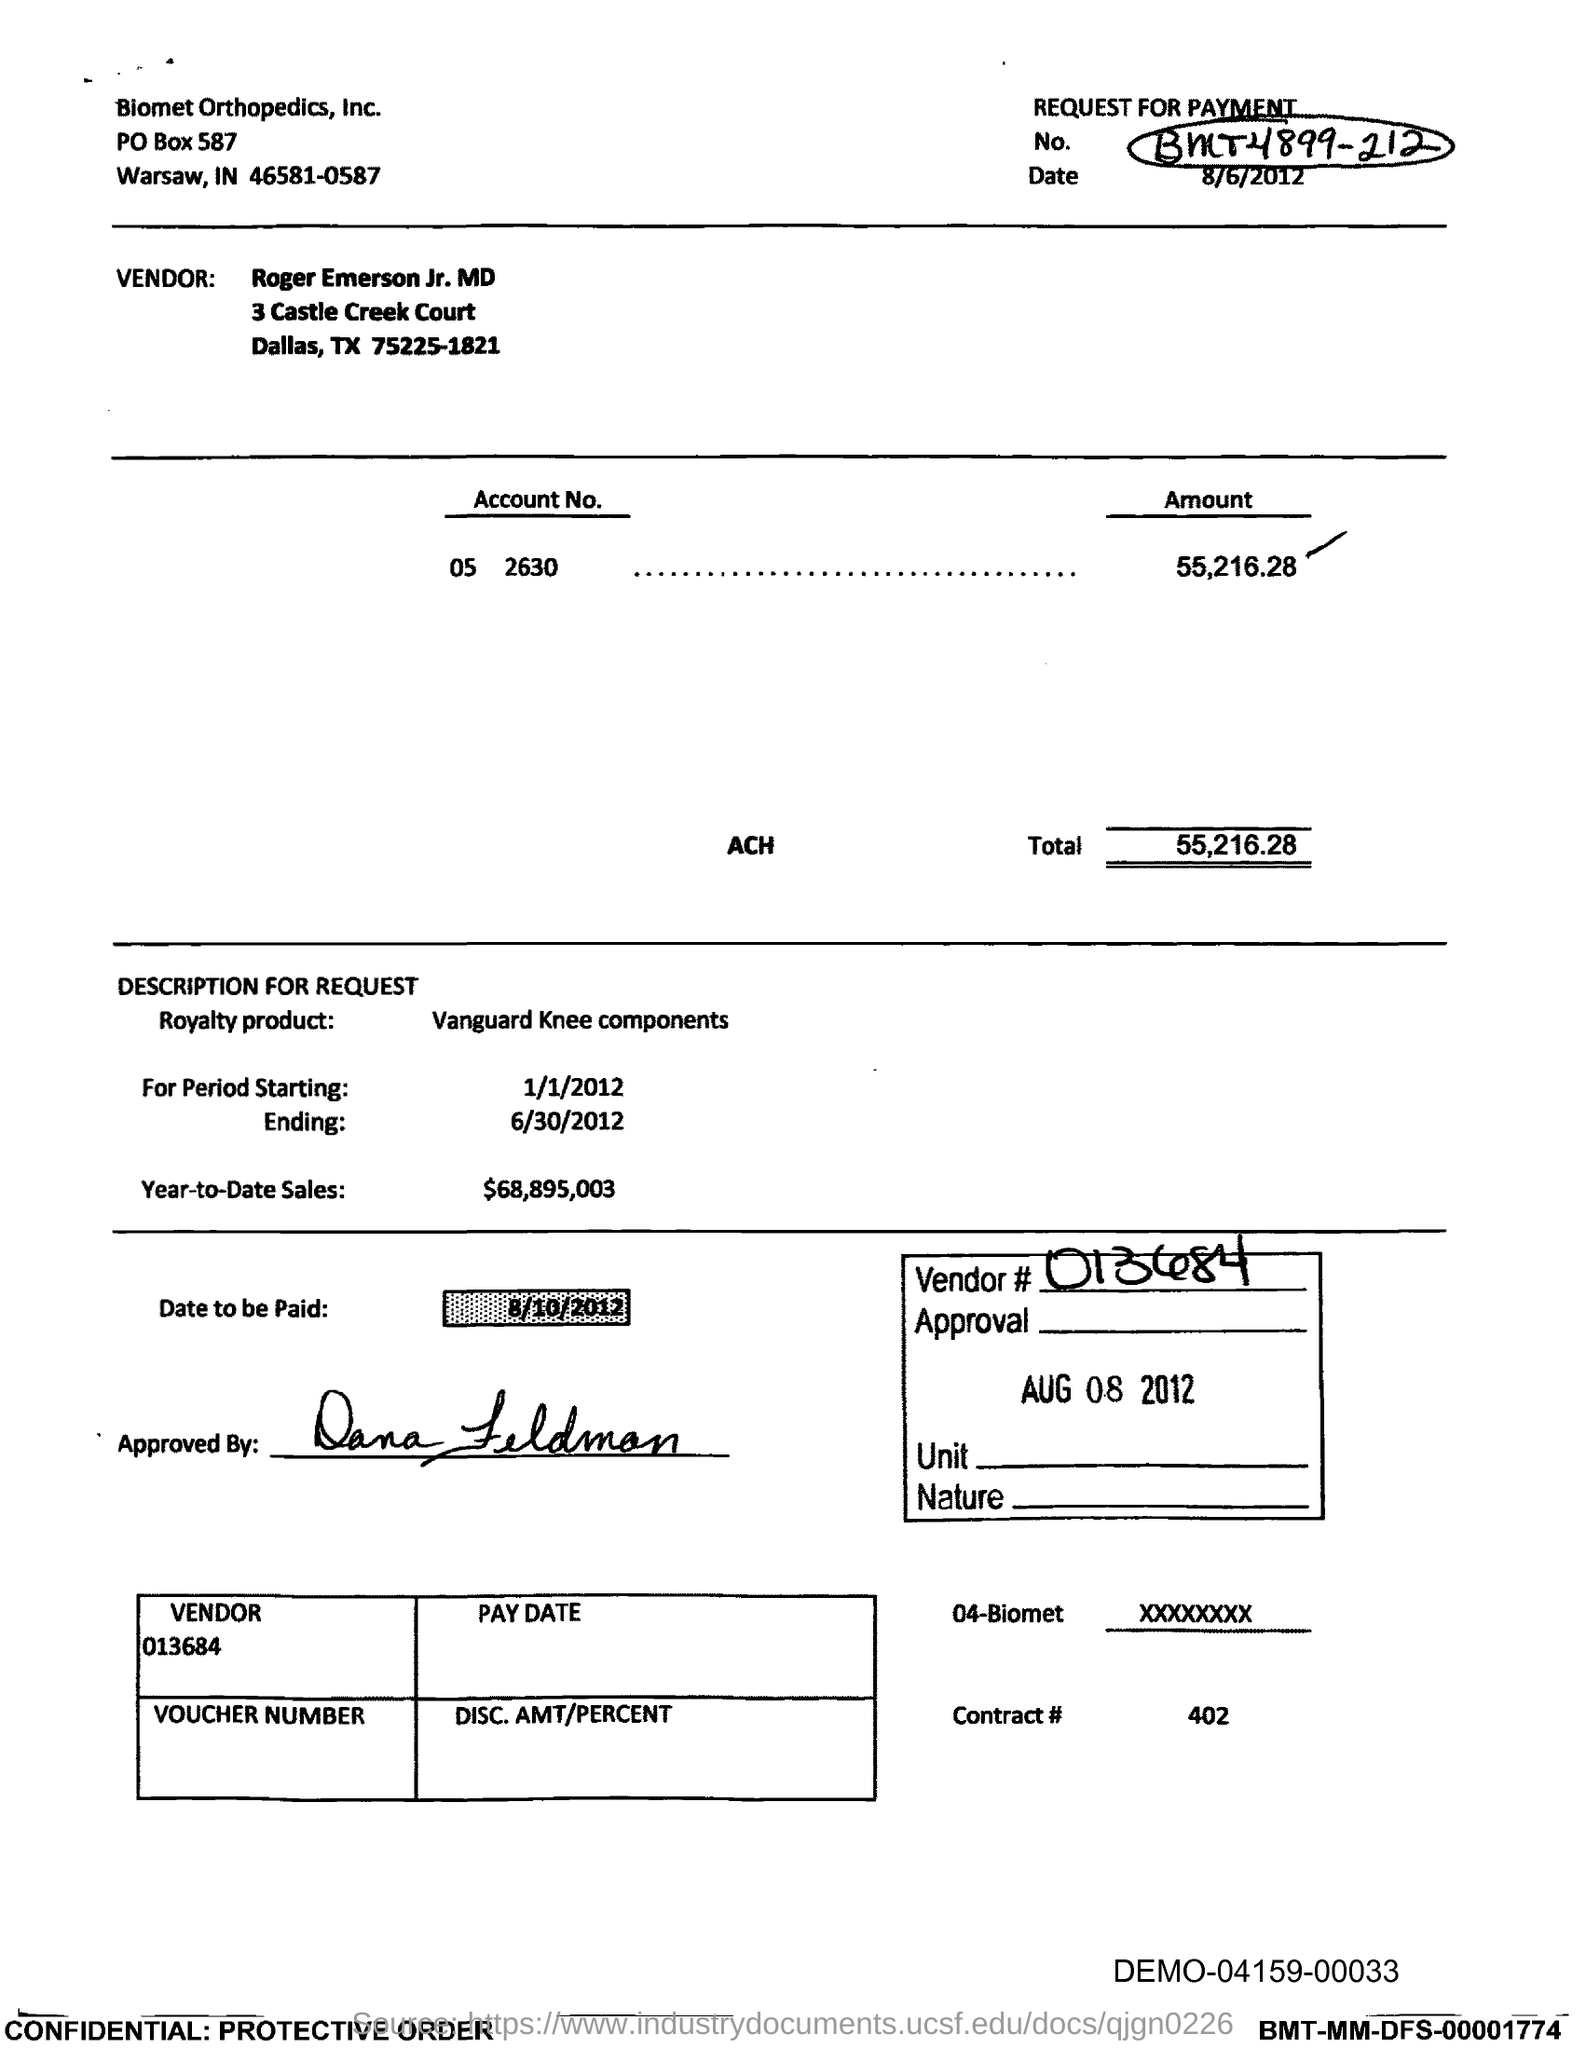Highlight a few significant elements in this photo. As of today, the year-to-date sales have reached a total of $68,895,003. The total is 55,216.28 dollars. On what date is the payment due? The ending period is 6/30/2012. As of January 1, 2012, the starting period has begun. 